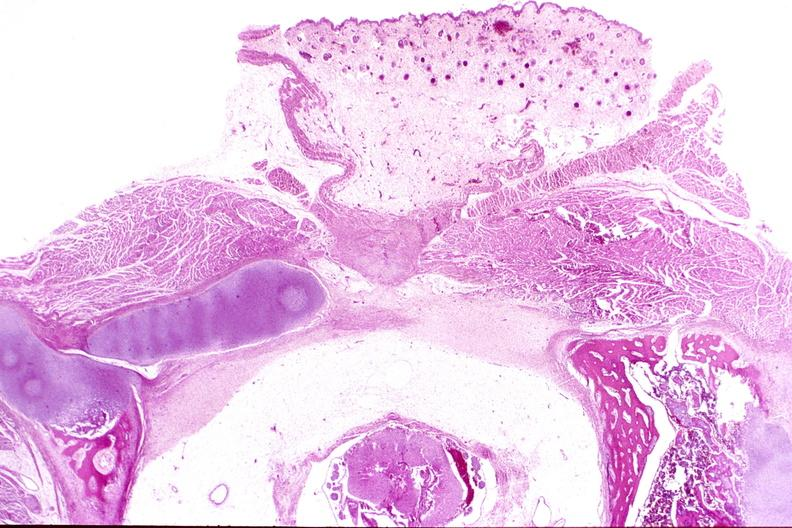s median lobe hyperplasia with marked cystitis and bladder hypertrophy ureter present?
Answer the question using a single word or phrase. No 